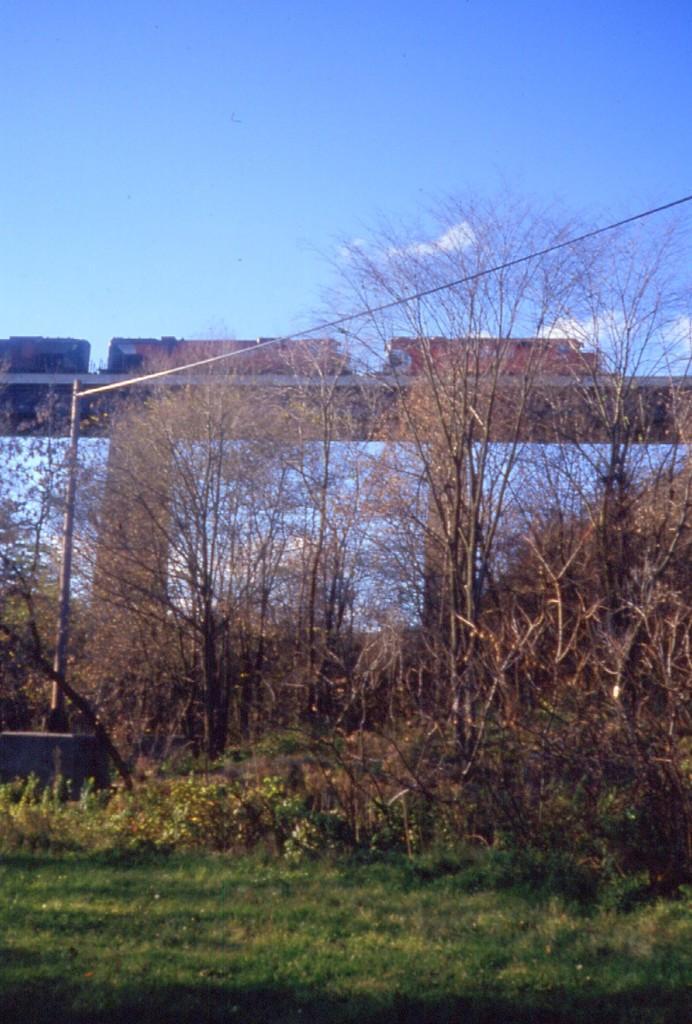Can you describe this image briefly? In this picture we can see grass at the bottom, in the background there is a bridge and some trees, on the left side we can see a pole, there is the sky at the top of the picture, it looks like a vehicle on the bridge. 